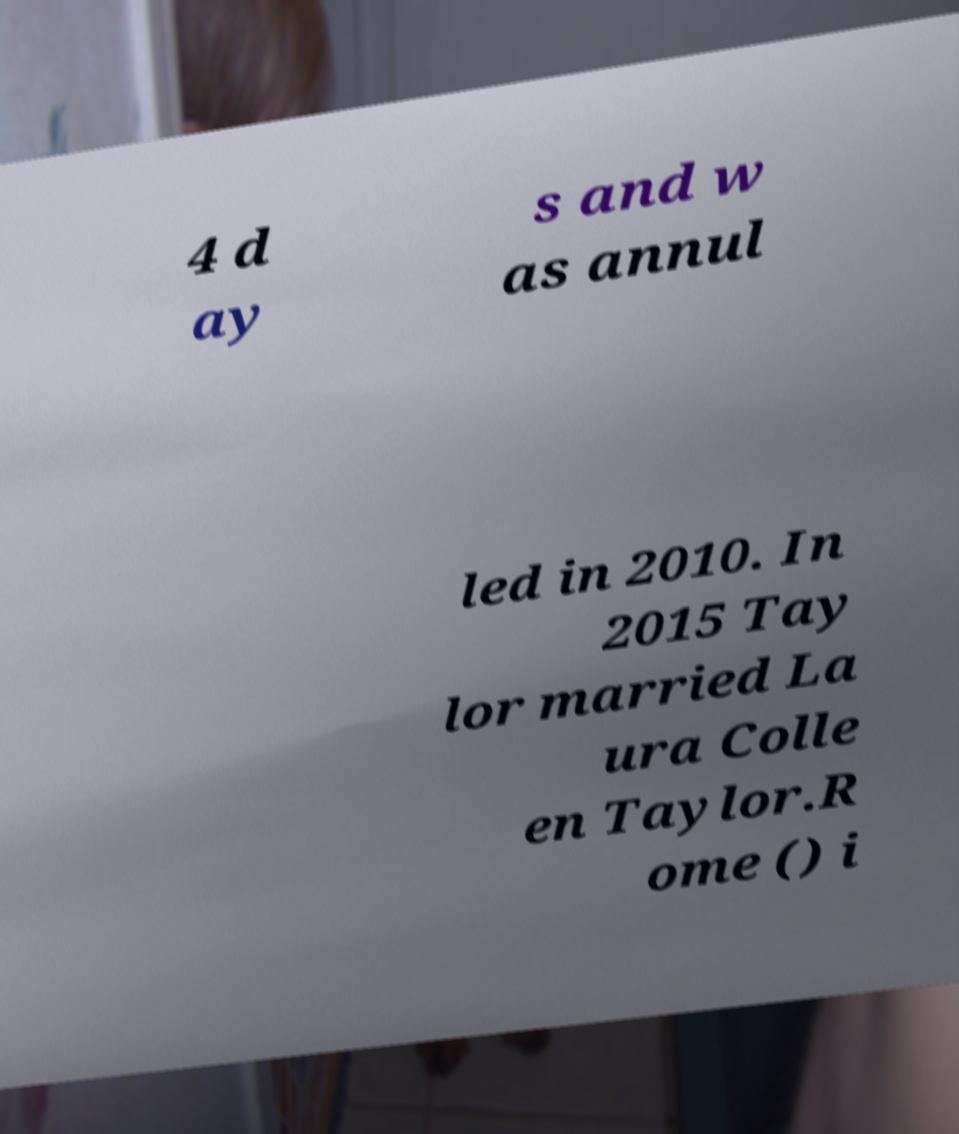Can you read and provide the text displayed in the image?This photo seems to have some interesting text. Can you extract and type it out for me? 4 d ay s and w as annul led in 2010. In 2015 Tay lor married La ura Colle en Taylor.R ome () i 